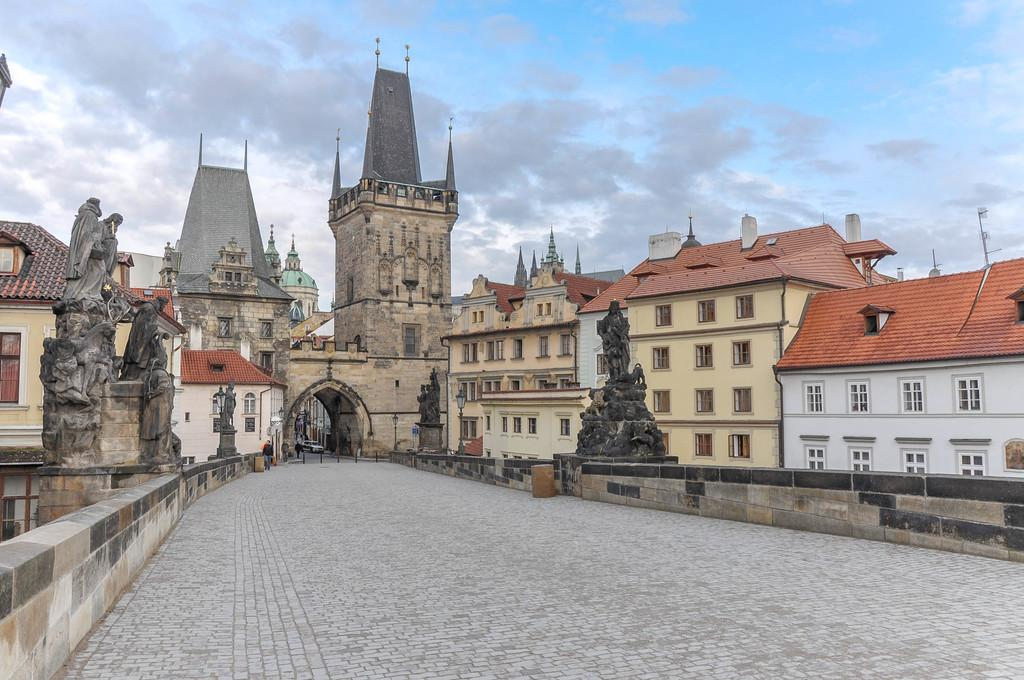What can be seen running through the image? There is a path in the image. What type of structures are present in the image? There are buildings in the image. Are there any artistic features in the image? Yes, there are statues in the image. What is visible in the background of the image? The sky is visible in the background of the image. How would you describe the weather based on the sky in the image? The sky appears to be cloudy in the image. What type of pet can be seen in the image? There is no pet visible in the image. Where is the hall located in the image? There is no hall present in the image. 